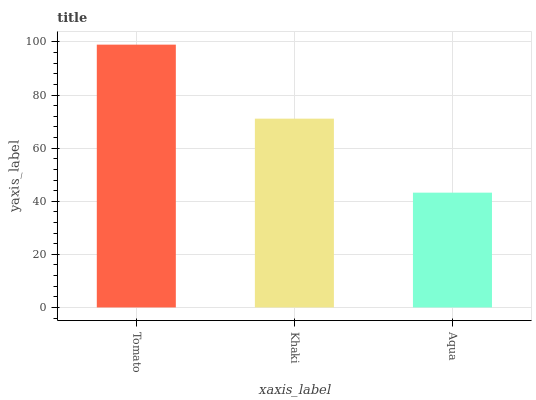Is Aqua the minimum?
Answer yes or no. Yes. Is Tomato the maximum?
Answer yes or no. Yes. Is Khaki the minimum?
Answer yes or no. No. Is Khaki the maximum?
Answer yes or no. No. Is Tomato greater than Khaki?
Answer yes or no. Yes. Is Khaki less than Tomato?
Answer yes or no. Yes. Is Khaki greater than Tomato?
Answer yes or no. No. Is Tomato less than Khaki?
Answer yes or no. No. Is Khaki the high median?
Answer yes or no. Yes. Is Khaki the low median?
Answer yes or no. Yes. Is Aqua the high median?
Answer yes or no. No. Is Aqua the low median?
Answer yes or no. No. 